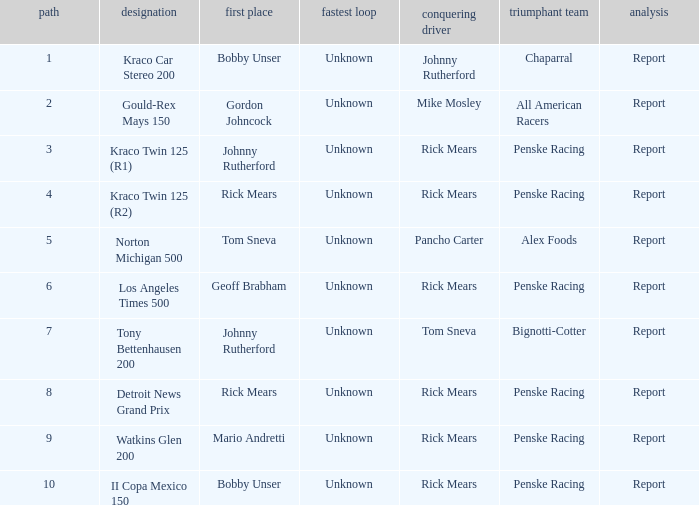What are the races that johnny rutherford has won? Kraco Car Stereo 200. 